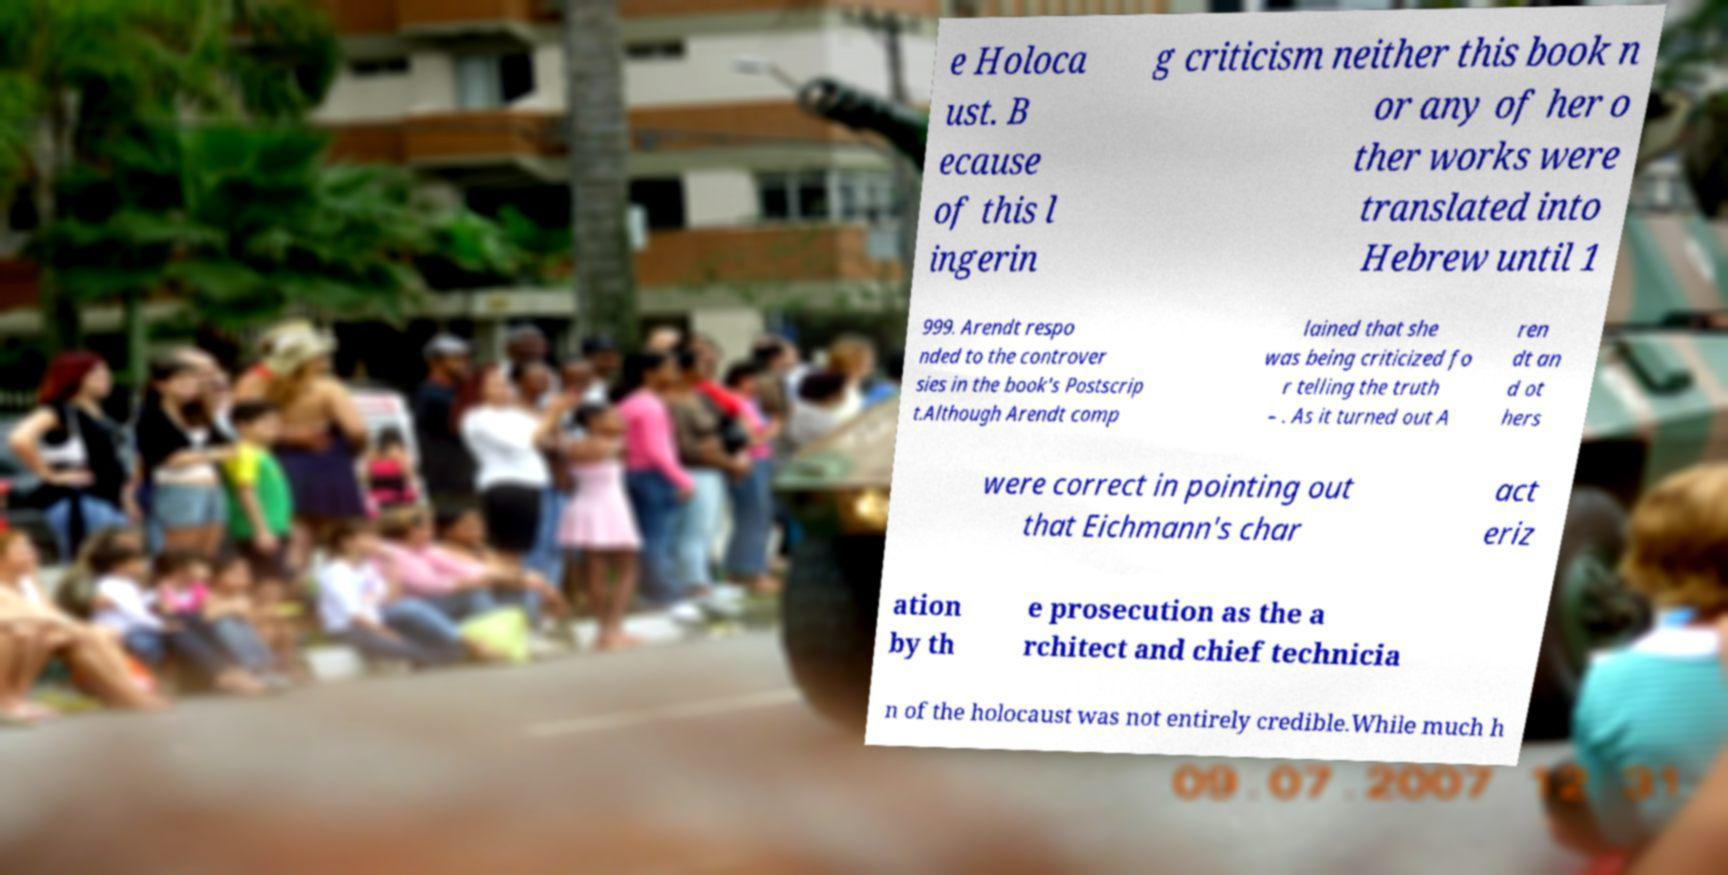There's text embedded in this image that I need extracted. Can you transcribe it verbatim? e Holoca ust. B ecause of this l ingerin g criticism neither this book n or any of her o ther works were translated into Hebrew until 1 999. Arendt respo nded to the controver sies in the book's Postscrip t.Although Arendt comp lained that she was being criticized fo r telling the truth – . As it turned out A ren dt an d ot hers were correct in pointing out that Eichmann's char act eriz ation by th e prosecution as the a rchitect and chief technicia n of the holocaust was not entirely credible.While much h 